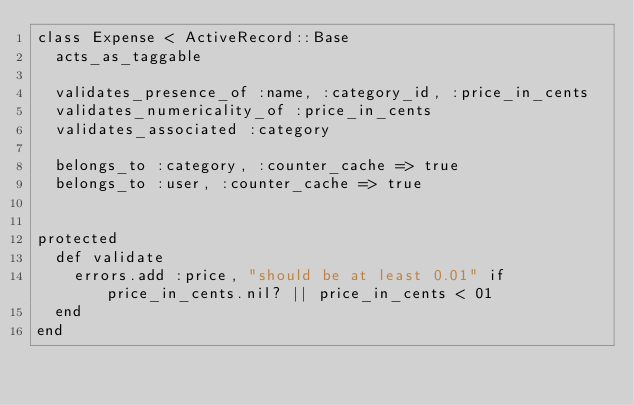Convert code to text. <code><loc_0><loc_0><loc_500><loc_500><_Ruby_>class Expense < ActiveRecord::Base
  acts_as_taggable
  
  validates_presence_of :name, :category_id, :price_in_cents
  validates_numericality_of :price_in_cents
  validates_associated :category
  
  belongs_to :category, :counter_cache => true
  belongs_to :user, :counter_cache => true
  
  
protected
  def validate
    errors.add :price, "should be at least 0.01" if price_in_cents.nil? || price_in_cents < 01
  end
end
</code> 